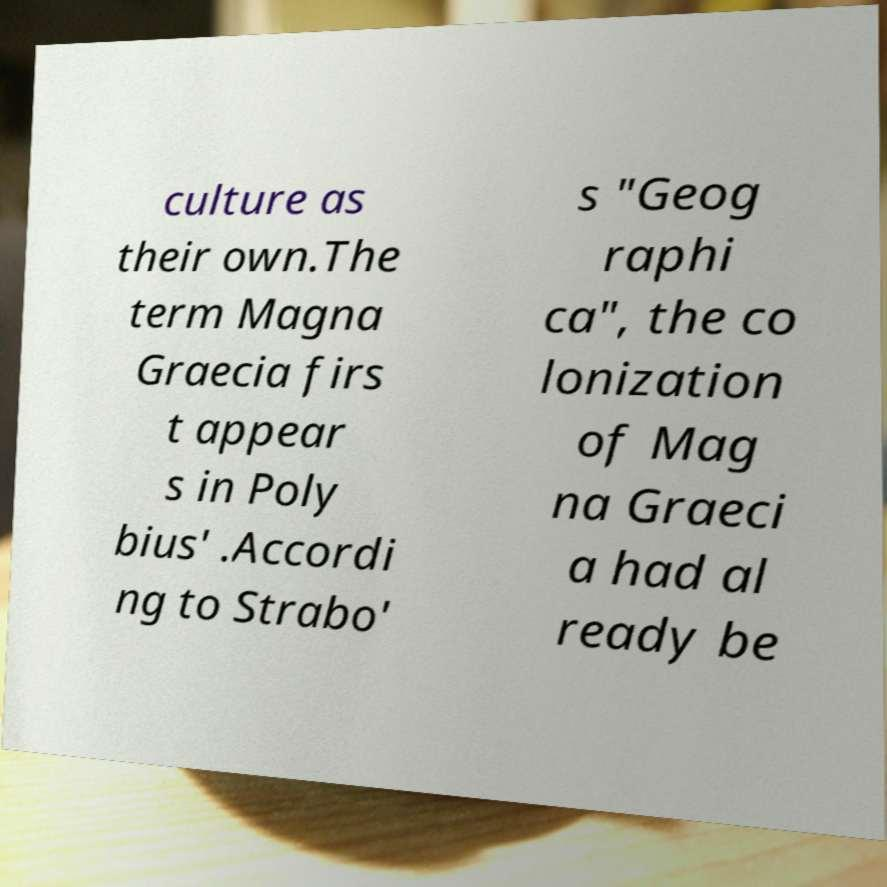What messages or text are displayed in this image? I need them in a readable, typed format. culture as their own.The term Magna Graecia firs t appear s in Poly bius' .Accordi ng to Strabo' s "Geog raphi ca", the co lonization of Mag na Graeci a had al ready be 